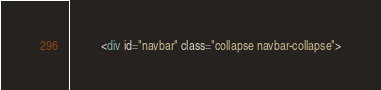<code> <loc_0><loc_0><loc_500><loc_500><_HTML_>          <div id="navbar" class="collapse navbar-collapse"></code> 